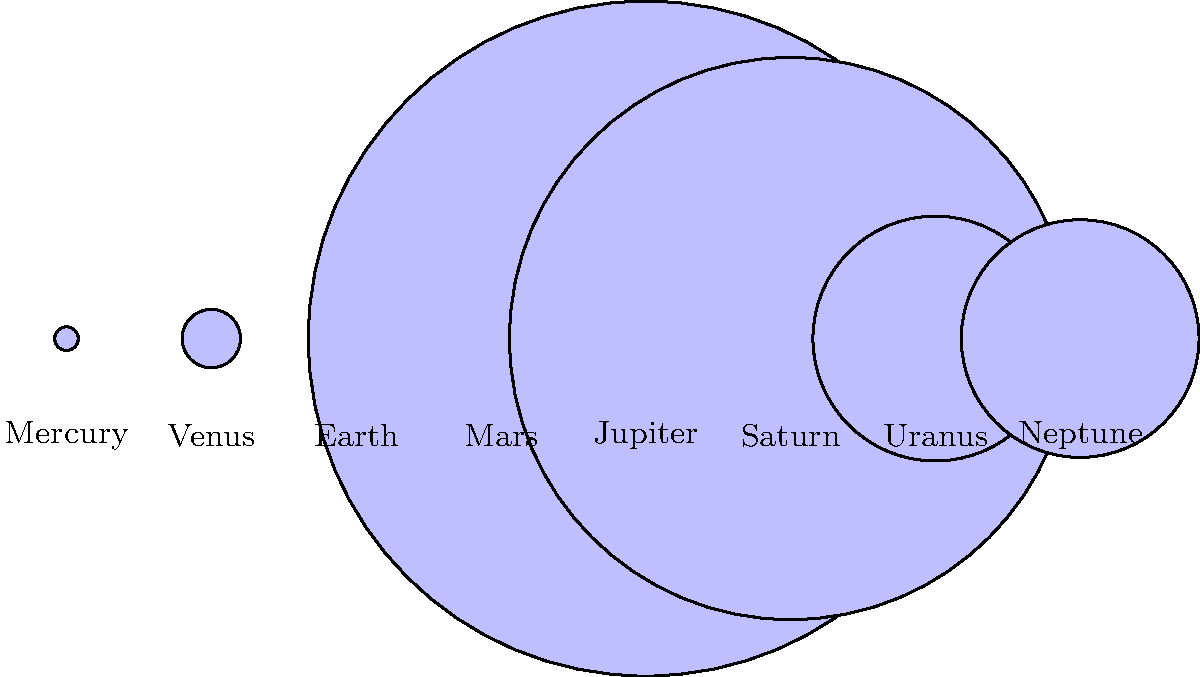In the image above, the planets of our solar system are represented by scaled circles. Which planet, often associated with the color red in pop culture (much like the bold red lipstick Carly Rae Jepsen sometimes wears in her music videos), appears to be the second smallest? To answer this question, we need to follow these steps:

1. Recall that Mars is often associated with the color red in pop culture.
2. Examine the scaled circular representations of the planets in the image.
3. Identify Mars among the planets.
4. Compare the size of Mars to the other planets.

Looking at the image:
1. Mercury (leftmost) is the smallest.
2. Mars is the fourth planet from the left.
3. Venus and Earth (second and third from left) are noticeably larger than Mars.
4. The gas giants (Jupiter, Saturn, Uranus, and Neptune) are all much larger than Mars.
5. Mars appears to be the second smallest planet after Mercury.

The relative sizes in the image reflect the actual relative sizes of the planets:
- Mercury diameter: 4,879 km
- Mars diameter: 6,779 km
- Venus diameter: 12,104 km
- Earth diameter: 12,742 km

This confirms that Mars is indeed the second smallest planet in our solar system.
Answer: Mars 